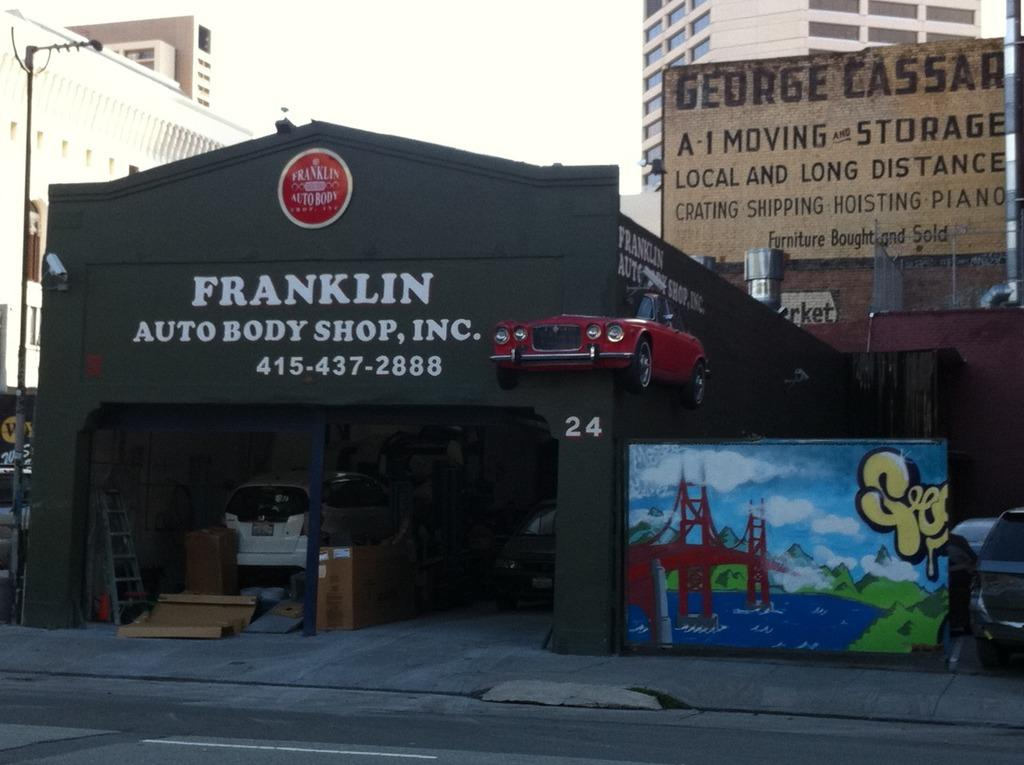<image>
Give a short and clear explanation of the subsequent image. A body shop called Franklin Auto Body Shop 